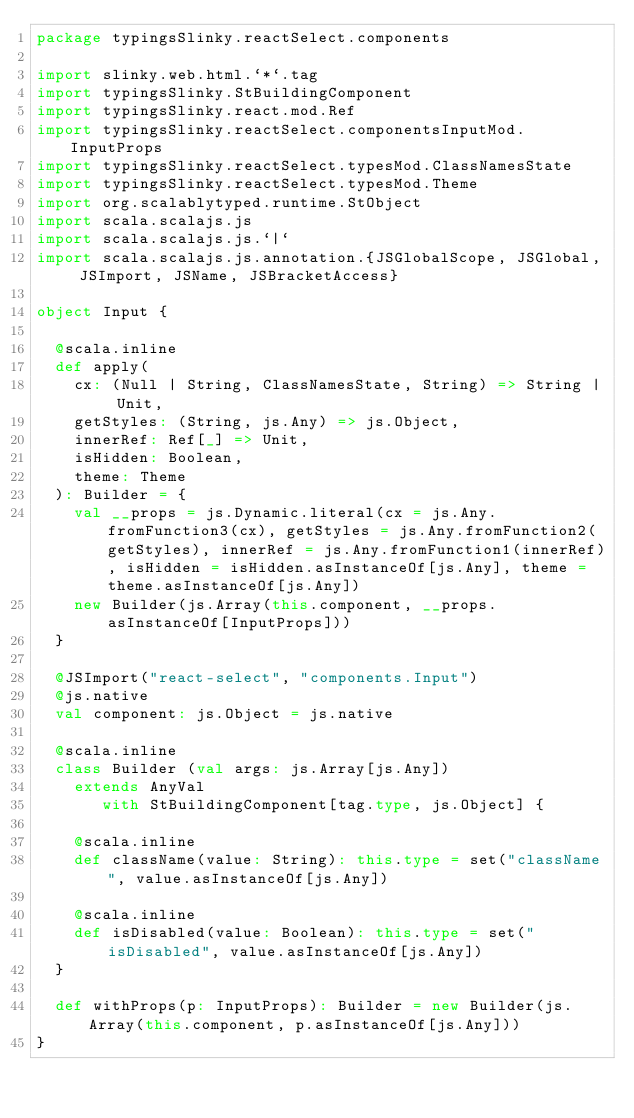<code> <loc_0><loc_0><loc_500><loc_500><_Scala_>package typingsSlinky.reactSelect.components

import slinky.web.html.`*`.tag
import typingsSlinky.StBuildingComponent
import typingsSlinky.react.mod.Ref
import typingsSlinky.reactSelect.componentsInputMod.InputProps
import typingsSlinky.reactSelect.typesMod.ClassNamesState
import typingsSlinky.reactSelect.typesMod.Theme
import org.scalablytyped.runtime.StObject
import scala.scalajs.js
import scala.scalajs.js.`|`
import scala.scalajs.js.annotation.{JSGlobalScope, JSGlobal, JSImport, JSName, JSBracketAccess}

object Input {
  
  @scala.inline
  def apply(
    cx: (Null | String, ClassNamesState, String) => String | Unit,
    getStyles: (String, js.Any) => js.Object,
    innerRef: Ref[_] => Unit,
    isHidden: Boolean,
    theme: Theme
  ): Builder = {
    val __props = js.Dynamic.literal(cx = js.Any.fromFunction3(cx), getStyles = js.Any.fromFunction2(getStyles), innerRef = js.Any.fromFunction1(innerRef), isHidden = isHidden.asInstanceOf[js.Any], theme = theme.asInstanceOf[js.Any])
    new Builder(js.Array(this.component, __props.asInstanceOf[InputProps]))
  }
  
  @JSImport("react-select", "components.Input")
  @js.native
  val component: js.Object = js.native
  
  @scala.inline
  class Builder (val args: js.Array[js.Any])
    extends AnyVal
       with StBuildingComponent[tag.type, js.Object] {
    
    @scala.inline
    def className(value: String): this.type = set("className", value.asInstanceOf[js.Any])
    
    @scala.inline
    def isDisabled(value: Boolean): this.type = set("isDisabled", value.asInstanceOf[js.Any])
  }
  
  def withProps(p: InputProps): Builder = new Builder(js.Array(this.component, p.asInstanceOf[js.Any]))
}
</code> 